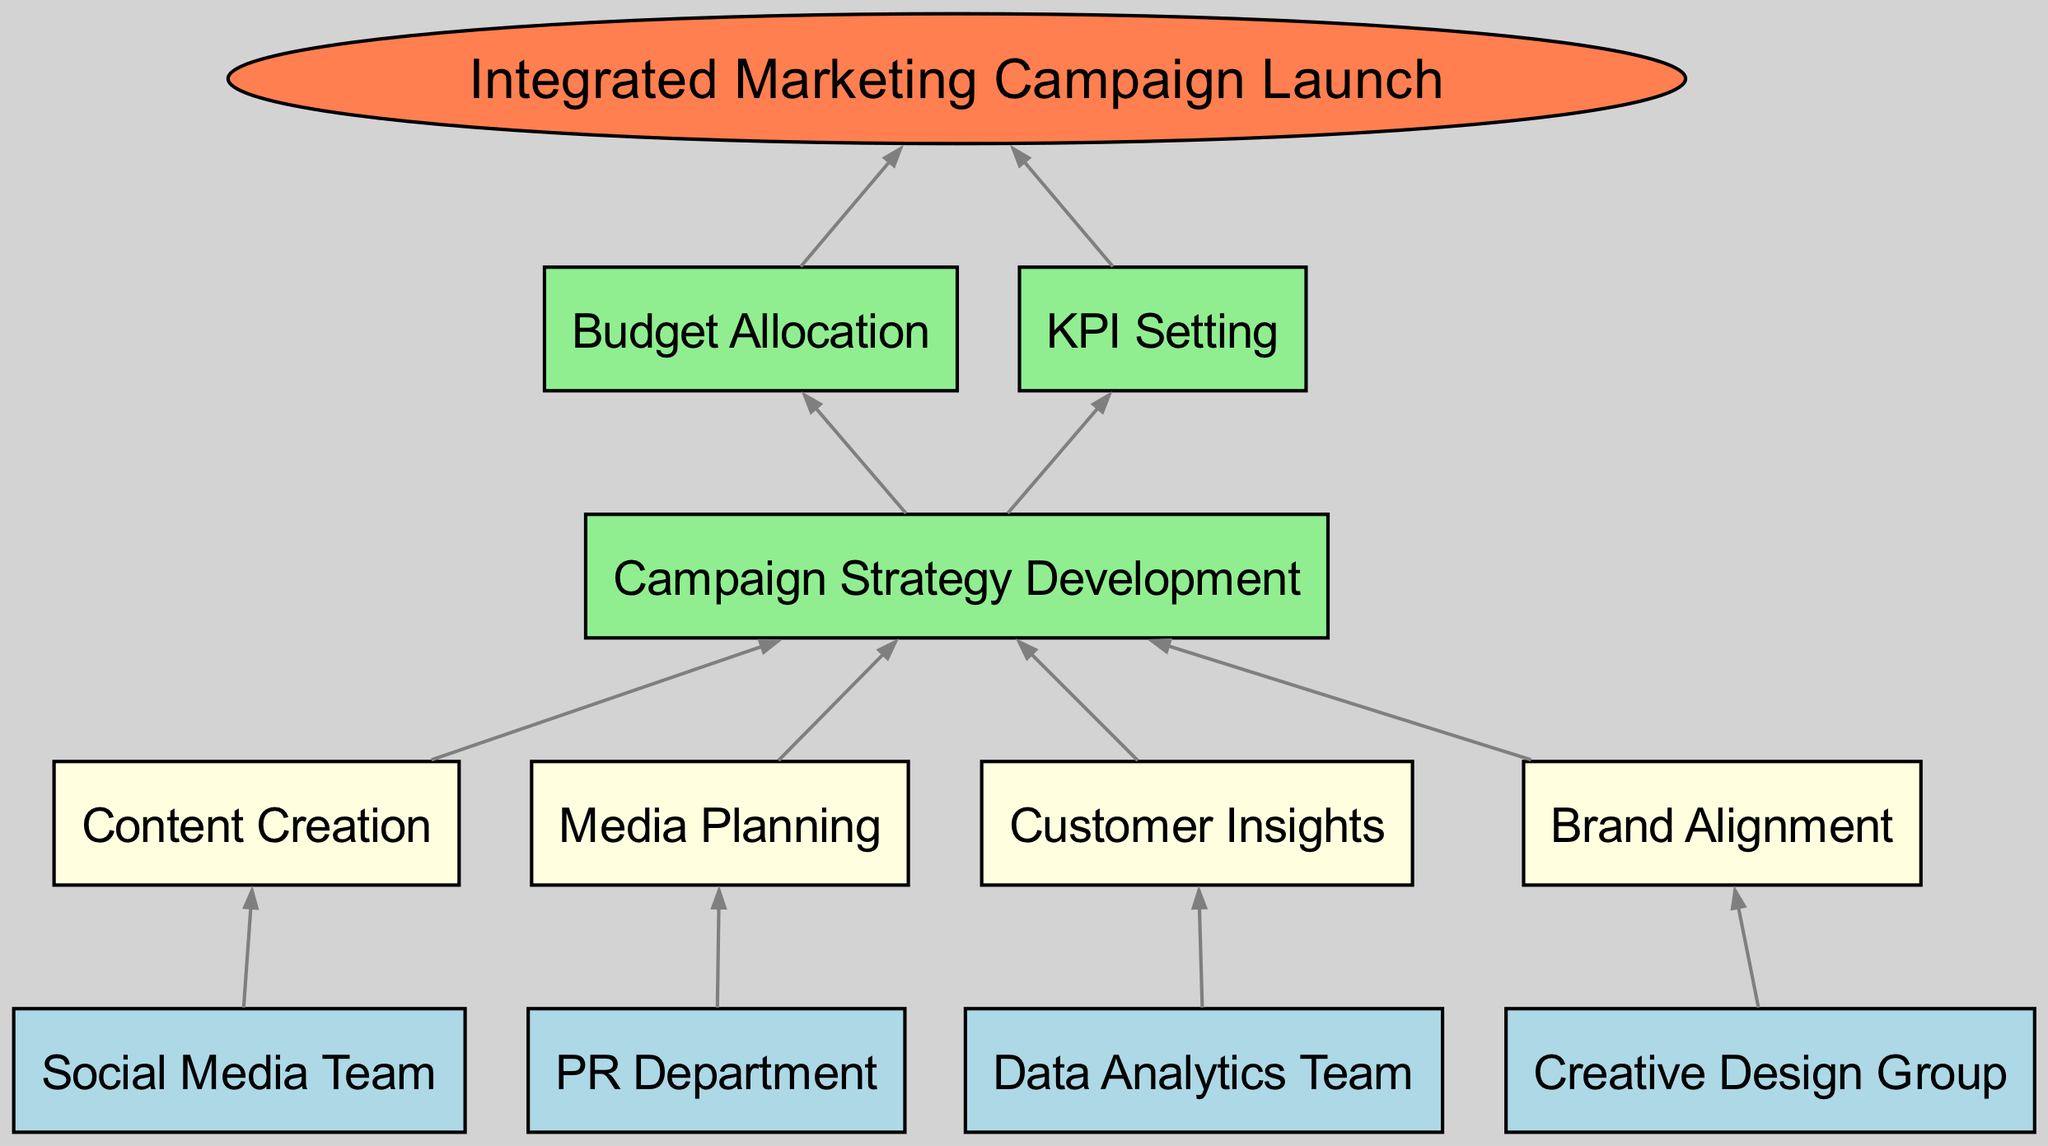What's the top element of the flow chart? The top element, as indicated in the diagram, represents the ultimate goal of the process, which is to launch an integrated marketing campaign.
Answer: Integrated Marketing Campaign Launch How many starting elements are there? Counting the nodes listed in the startingElements section, we find four distinct teams that initiate the process.
Answer: 4 Which team is responsible for content creation? By following the arrows in the diagram, we observe that the Social Media Team contributes directly to content creation.
Answer: Social Media Team What are the intermediate elements in the process? Referring to the intermediateElements section, we list the key activities that occur after the starting phase. These include content creation, media planning, customer insights, and brand alignment.
Answer: Content Creation, Media Planning, Customer Insights, Brand Alignment Which higher level element comes directly after Campaign Strategy Development? Following the directional flow, we see that Budget Allocation and KPI Setting both arise from Campaign Strategy Development; however, the first one encountered in the flow is Budget Allocation.
Answer: Budget Allocation How many edges connect the starting elements to the intermediate elements? There are four connections, each linking one starting element to an intermediate element based on the defined connections in the diagram.
Answer: 4 What is the relationship between Customer Insights and Campaign Strategy Development? The arrow indicating the flow shows that customer insights feed directly into the campaign strategy development process, establishing a strong connection between the two.
Answer: Customer Insights feeds into Campaign Strategy Development Which element leads to KPI Setting? The diagram shows that the first stage of strategy development influences KPI setting, establishing a direct link from Campaign Strategy Development.
Answer: Campaign Strategy Development How many total elements are there in this flow chart? By counting the starting, intermediate, higher-level elements, and the top element, we arrive at a total of eleven distinct elements in the diagram.
Answer: 11 